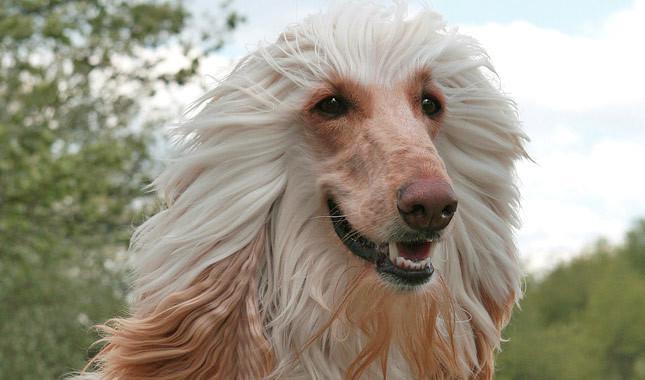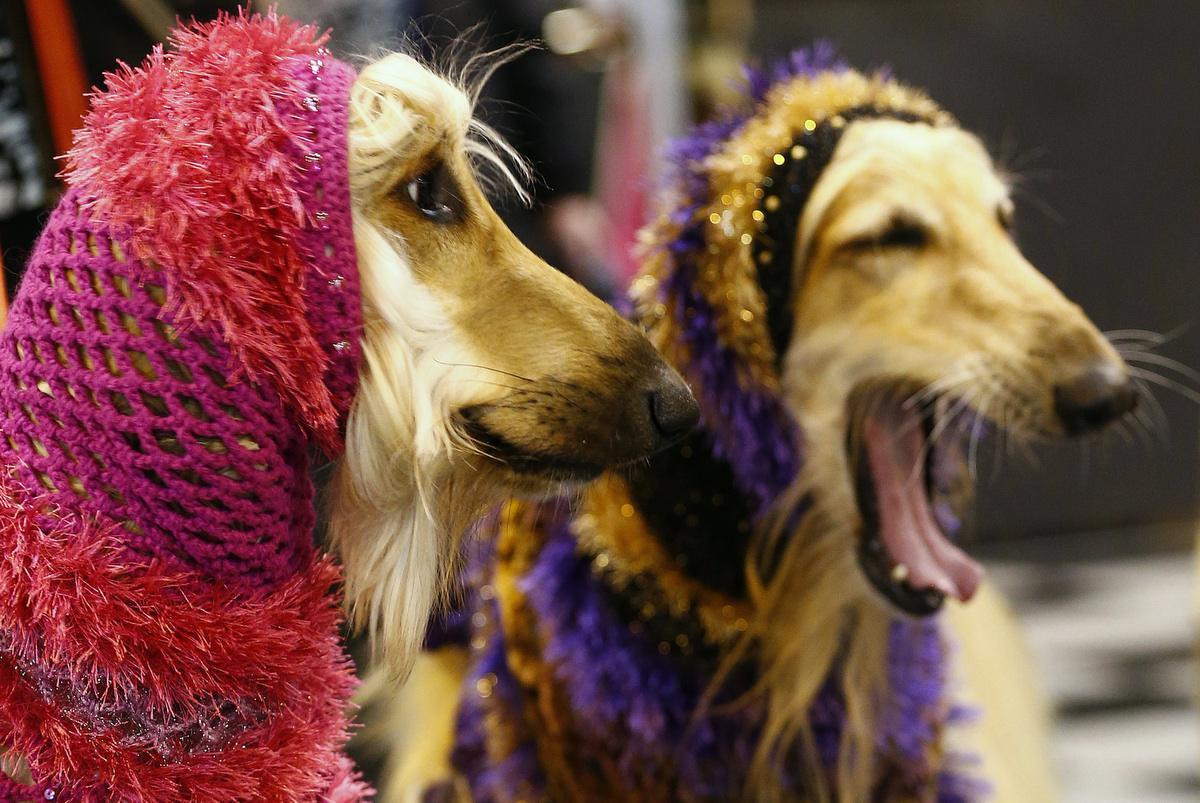The first image is the image on the left, the second image is the image on the right. Considering the images on both sides, is "The right and left image contains the same number of dogs." valid? Answer yes or no. No. The first image is the image on the left, the second image is the image on the right. Given the left and right images, does the statement "There are no fewer than 3 dogs." hold true? Answer yes or no. Yes. 